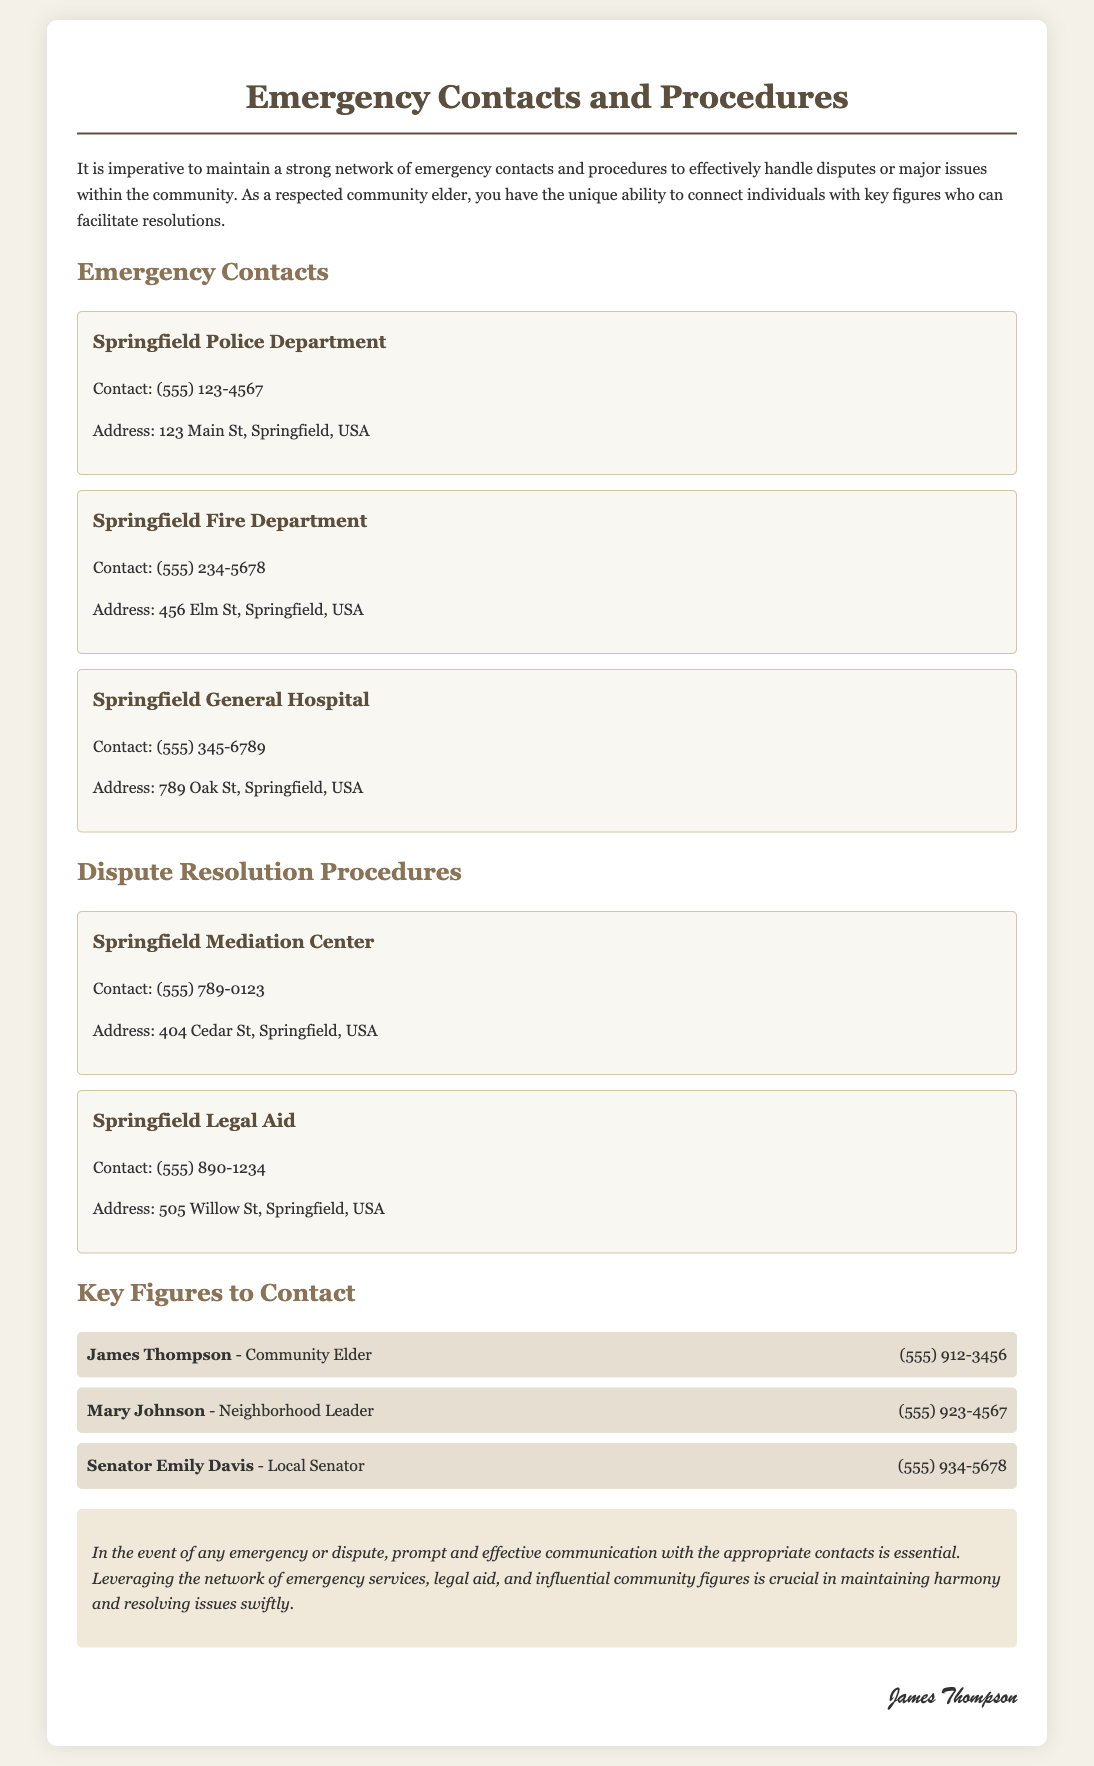what is the contact number for the Springfield Police Department? The contact number for the Springfield Police Department is listed in the Emergency Contacts section of the document.
Answer: (555) 123-4567 who is the local senator mentioned in the document? The document lists key figures, including the local senator, in the section titled Key Figures to Contact.
Answer: Senator Emily Davis what is the address of the Springfield General Hospital? The address is provided in the Emergency Contacts section, which details various emergency services.
Answer: 789 Oak St, Springfield, USA how many key figures are listed in the document? The number of key figures is found in the Key Figures to Contact section, where names and contact details are listed.
Answer: 3 which department's contact number is (555) 890-1234? The document includes multiple departments with their contact numbers; this one belongs to the organization listed in the Dispute Resolution Procedures section.
Answer: Springfield Legal Aid what type of center is the Springfield Mediation Center? The type of center is identified in the context of resolving disputes and is mentioned in the Dispute Resolution Procedures section.
Answer: Mediation Center 